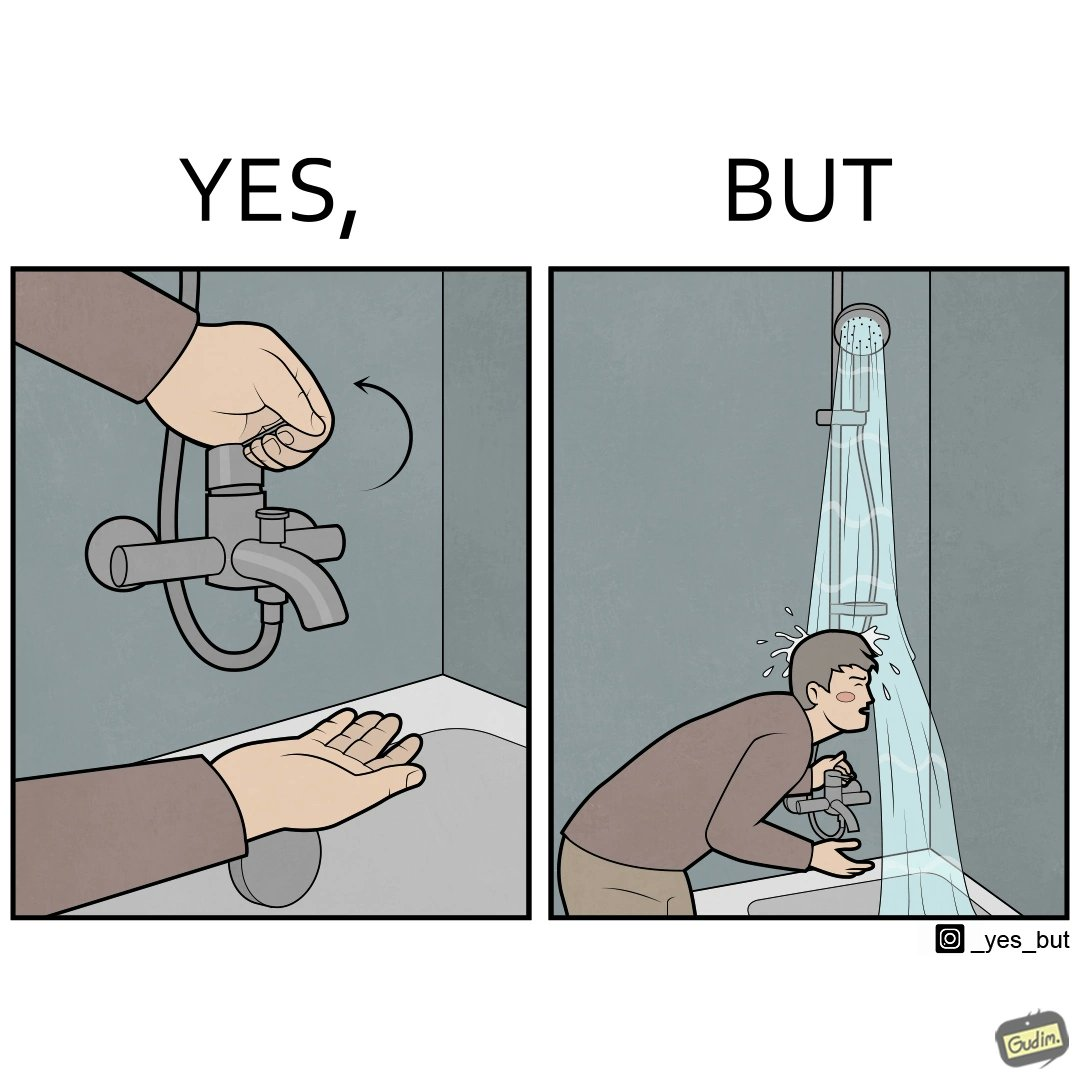What makes this image funny or satirical? The image is funny, as the person is trying to operate the tap, but water comes out of the handheld shower resting on a holder instead of the tap, making the person drenched in water. 